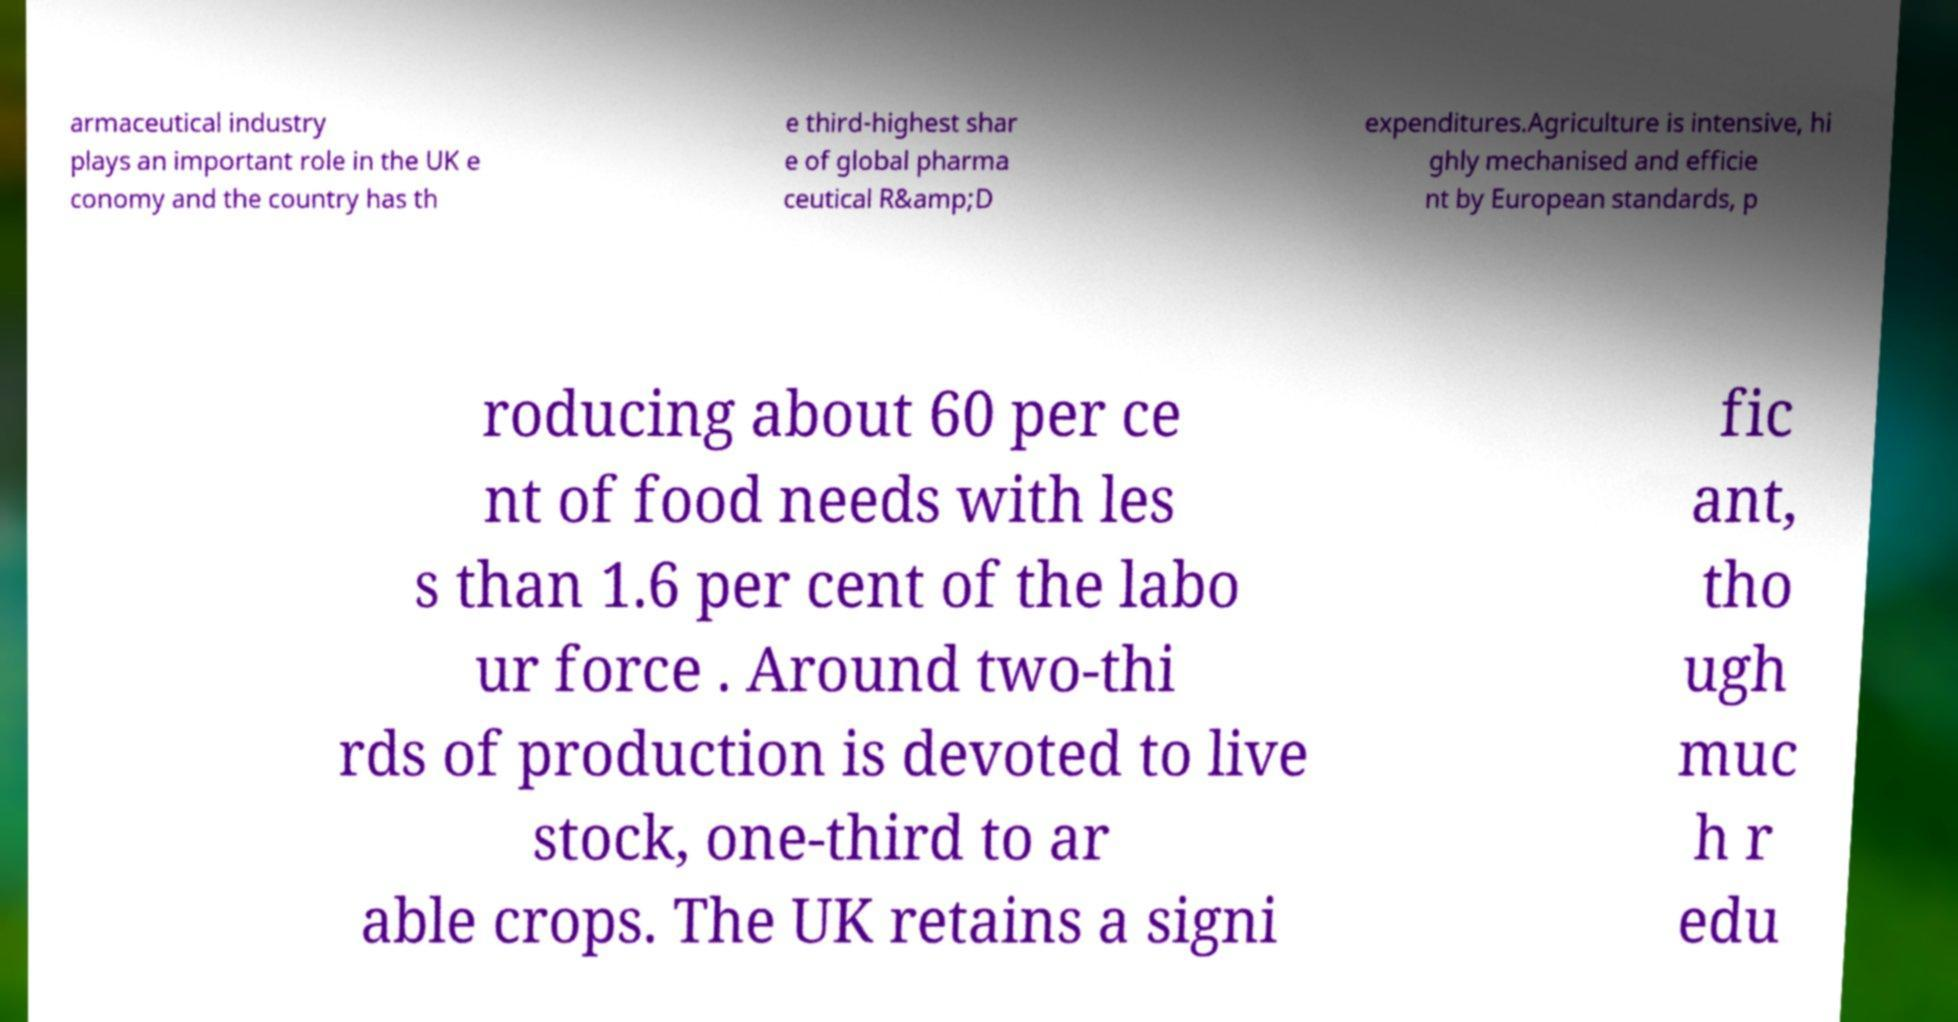Please identify and transcribe the text found in this image. armaceutical industry plays an important role in the UK e conomy and the country has th e third-highest shar e of global pharma ceutical R&amp;D expenditures.Agriculture is intensive, hi ghly mechanised and efficie nt by European standards, p roducing about 60 per ce nt of food needs with les s than 1.6 per cent of the labo ur force . Around two-thi rds of production is devoted to live stock, one-third to ar able crops. The UK retains a signi fic ant, tho ugh muc h r edu 